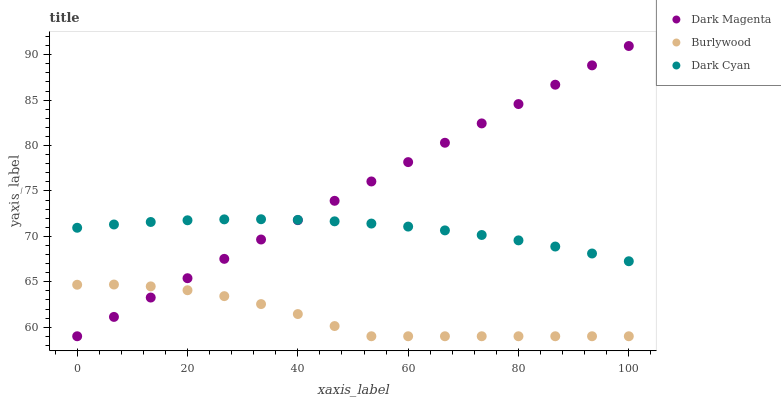Does Burlywood have the minimum area under the curve?
Answer yes or no. Yes. Does Dark Magenta have the maximum area under the curve?
Answer yes or no. Yes. Does Dark Cyan have the minimum area under the curve?
Answer yes or no. No. Does Dark Cyan have the maximum area under the curve?
Answer yes or no. No. Is Dark Magenta the smoothest?
Answer yes or no. Yes. Is Burlywood the roughest?
Answer yes or no. Yes. Is Dark Cyan the smoothest?
Answer yes or no. No. Is Dark Cyan the roughest?
Answer yes or no. No. Does Burlywood have the lowest value?
Answer yes or no. Yes. Does Dark Cyan have the lowest value?
Answer yes or no. No. Does Dark Magenta have the highest value?
Answer yes or no. Yes. Does Dark Cyan have the highest value?
Answer yes or no. No. Is Burlywood less than Dark Cyan?
Answer yes or no. Yes. Is Dark Cyan greater than Burlywood?
Answer yes or no. Yes. Does Dark Magenta intersect Burlywood?
Answer yes or no. Yes. Is Dark Magenta less than Burlywood?
Answer yes or no. No. Is Dark Magenta greater than Burlywood?
Answer yes or no. No. Does Burlywood intersect Dark Cyan?
Answer yes or no. No. 